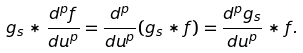<formula> <loc_0><loc_0><loc_500><loc_500>g _ { s } \ast \frac { d ^ { p } f } { d u ^ { p } } = \frac { d ^ { p } } { d u ^ { p } } ( g _ { s } \ast f ) = \frac { d ^ { p } g _ { s } } { d u ^ { p } } \ast f .</formula> 